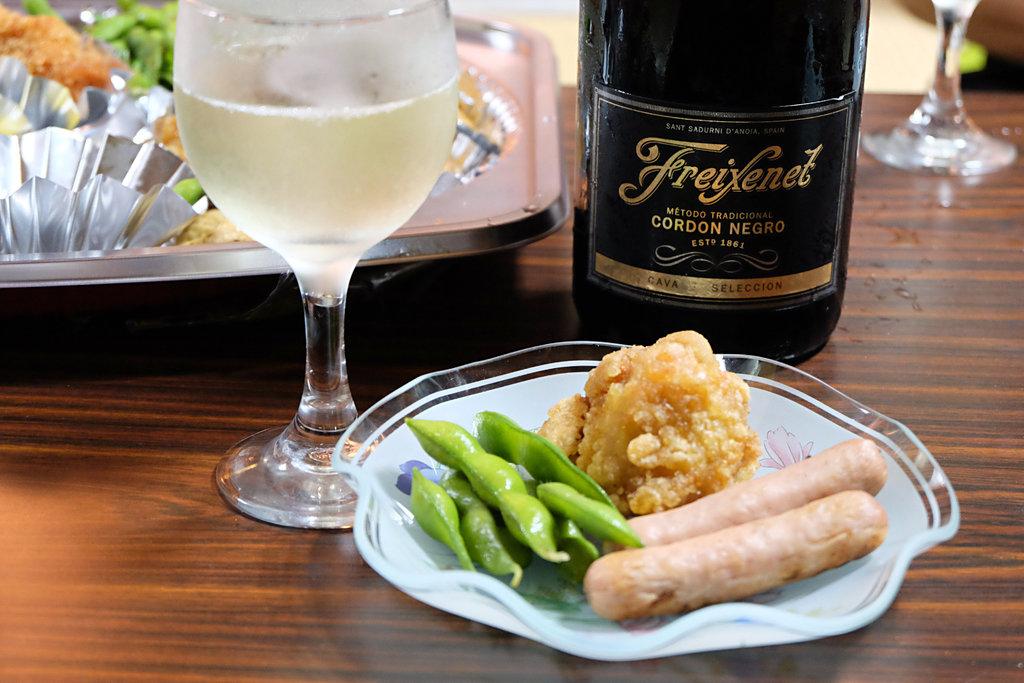What kind of wine is being served?
Provide a succinct answer. Freixenet. What is the name of the wine being served?
Your answer should be very brief. Freixenet. 